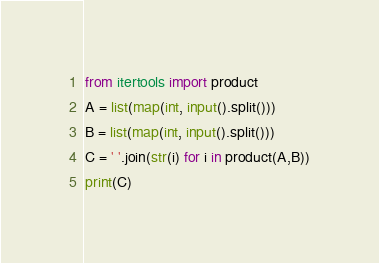Convert code to text. <code><loc_0><loc_0><loc_500><loc_500><_Python_>from itertools import product
A = list(map(int, input().split()))
B = list(map(int, input().split()))
C = ' '.join(str(i) for i in product(A,B))
print(C)</code> 